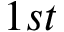<formula> <loc_0><loc_0><loc_500><loc_500>1 { s t }</formula> 